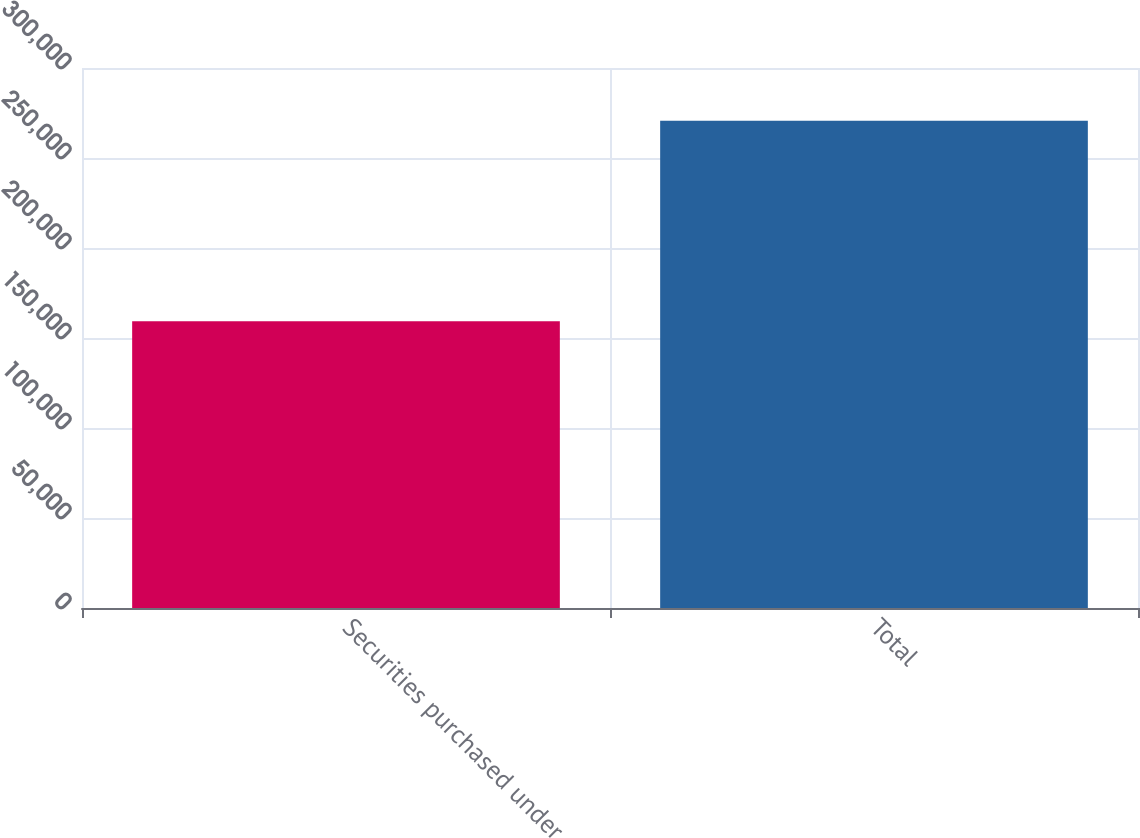Convert chart to OTSL. <chart><loc_0><loc_0><loc_500><loc_500><bar_chart><fcel>Securities purchased under<fcel>Total<nl><fcel>159364<fcel>270684<nl></chart> 